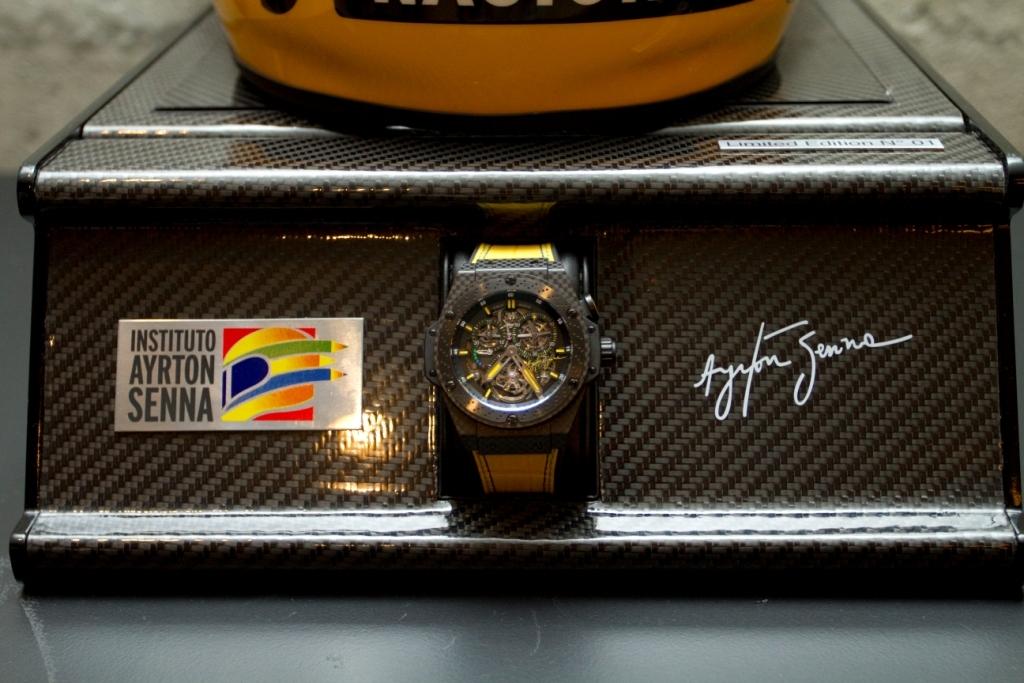Where is the institute on the label?
Your answer should be compact. Ayrton senna. Whose signature appears next to the watch?
Your response must be concise. Ayrton senna. 